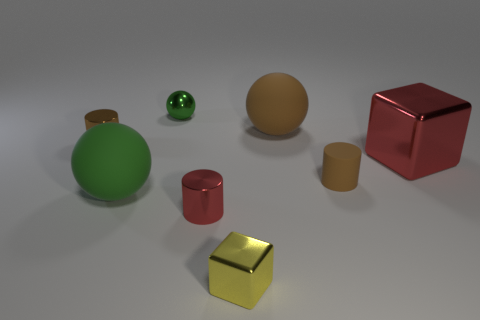Subtract all small red cylinders. How many cylinders are left? 2 Add 2 blue cylinders. How many objects exist? 10 Subtract all red cylinders. How many cylinders are left? 2 Subtract all balls. How many objects are left? 5 Subtract 2 balls. How many balls are left? 1 Subtract all green cubes. Subtract all red balls. How many cubes are left? 2 Subtract all cyan cylinders. How many yellow blocks are left? 1 Subtract all brown matte objects. Subtract all yellow blocks. How many objects are left? 5 Add 6 brown rubber things. How many brown rubber things are left? 8 Add 6 small blue spheres. How many small blue spheres exist? 6 